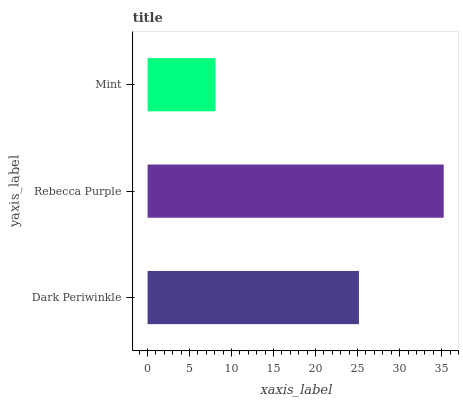Is Mint the minimum?
Answer yes or no. Yes. Is Rebecca Purple the maximum?
Answer yes or no. Yes. Is Rebecca Purple the minimum?
Answer yes or no. No. Is Mint the maximum?
Answer yes or no. No. Is Rebecca Purple greater than Mint?
Answer yes or no. Yes. Is Mint less than Rebecca Purple?
Answer yes or no. Yes. Is Mint greater than Rebecca Purple?
Answer yes or no. No. Is Rebecca Purple less than Mint?
Answer yes or no. No. Is Dark Periwinkle the high median?
Answer yes or no. Yes. Is Dark Periwinkle the low median?
Answer yes or no. Yes. Is Rebecca Purple the high median?
Answer yes or no. No. Is Rebecca Purple the low median?
Answer yes or no. No. 